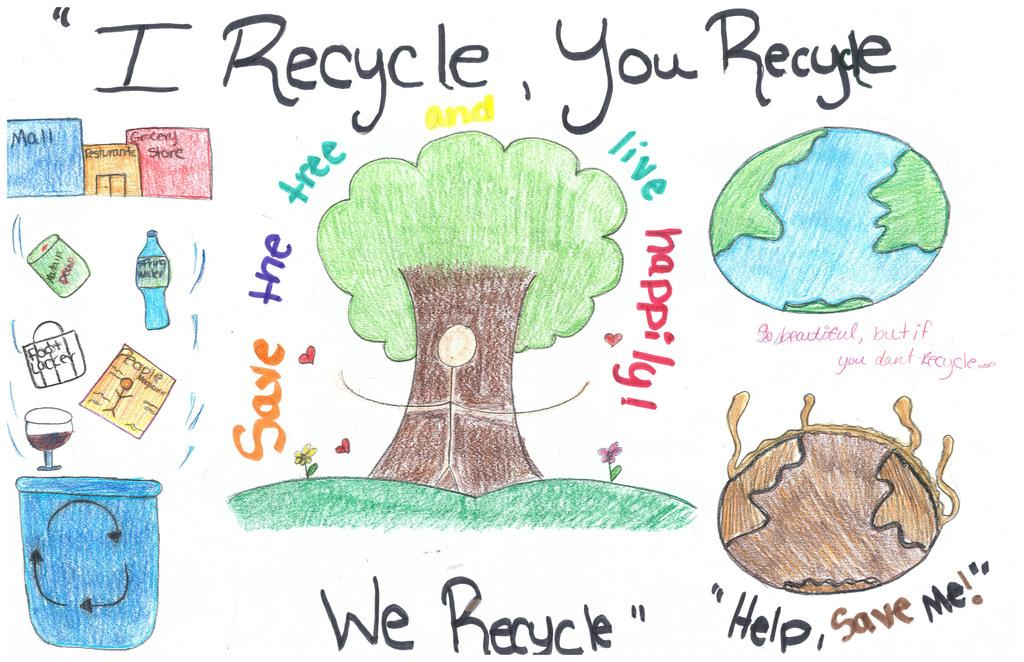What is depicted in the drawing in the image? There is a drawing of a tree in the image. What type of container is visible in the image? There is a glass in the image. What other type of container can be seen in the image? There is a bottle in the image. What is the third container-like object in the image? There is a bucket in the image. What type of plant is present in the image? There are flowers in the image. What else can be seen in the image besides the mentioned objects? There are other unspecified things in the image. Is there any text or writing in the image? Yes, there is something written on the image. What type of quilt is being used to cover the government building in the image? There is no quilt or government building present in the image. How does the recess affect the drawing of the tree in the image? There is no mention of a recess in the image, and it does not affect the drawing of the tree. 